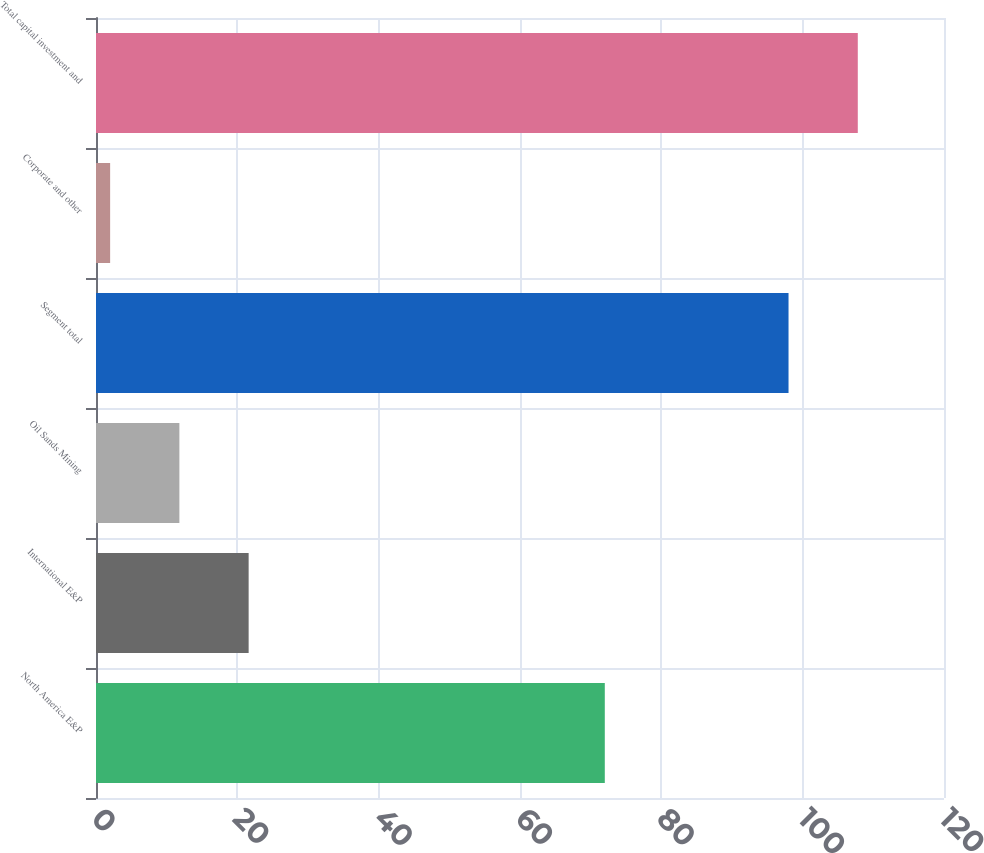Convert chart to OTSL. <chart><loc_0><loc_0><loc_500><loc_500><bar_chart><fcel>North America E&P<fcel>International E&P<fcel>Oil Sands Mining<fcel>Segment total<fcel>Corporate and other<fcel>Total capital investment and<nl><fcel>72<fcel>21.6<fcel>11.8<fcel>98<fcel>2<fcel>107.8<nl></chart> 